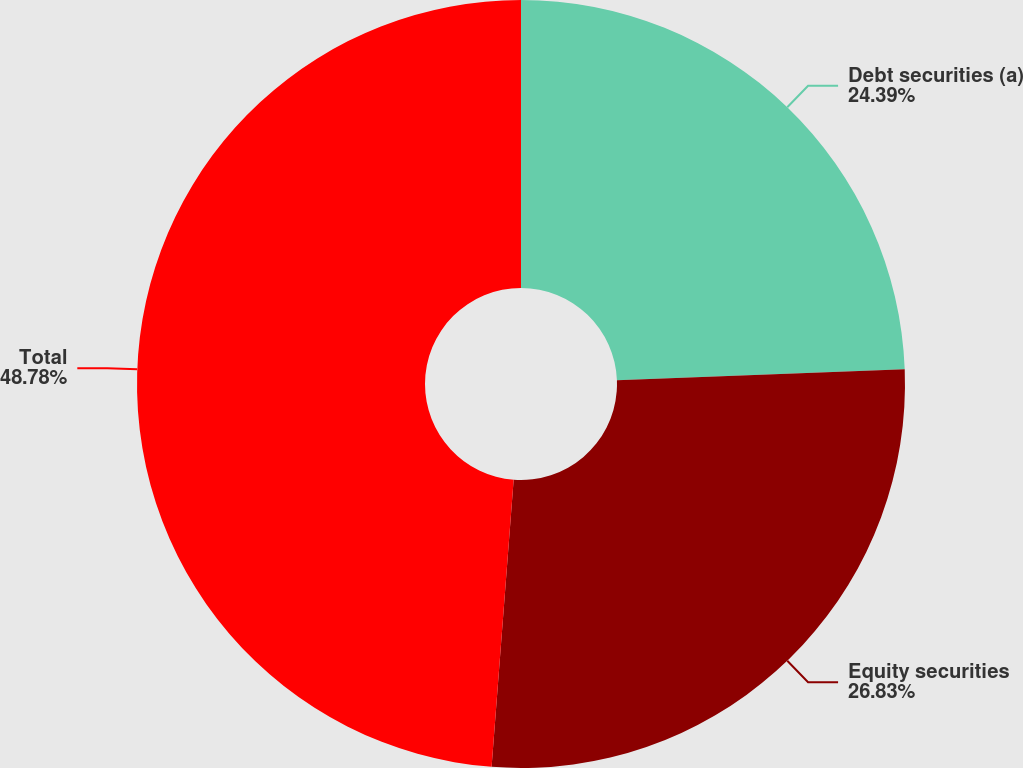Convert chart to OTSL. <chart><loc_0><loc_0><loc_500><loc_500><pie_chart><fcel>Debt securities (a)<fcel>Equity securities<fcel>Total<nl><fcel>24.39%<fcel>26.83%<fcel>48.78%<nl></chart> 